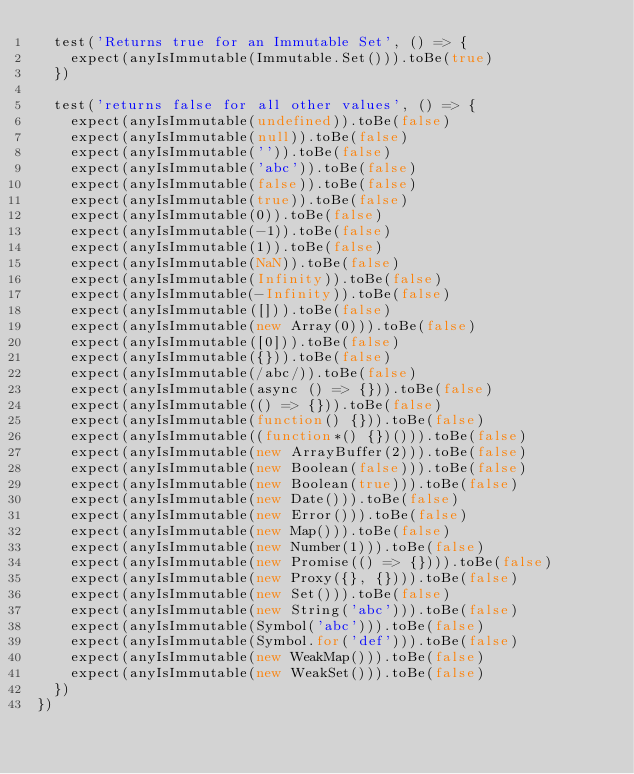<code> <loc_0><loc_0><loc_500><loc_500><_JavaScript_>  test('Returns true for an Immutable Set', () => {
    expect(anyIsImmutable(Immutable.Set())).toBe(true)
  })

  test('returns false for all other values', () => {
    expect(anyIsImmutable(undefined)).toBe(false)
    expect(anyIsImmutable(null)).toBe(false)
    expect(anyIsImmutable('')).toBe(false)
    expect(anyIsImmutable('abc')).toBe(false)
    expect(anyIsImmutable(false)).toBe(false)
    expect(anyIsImmutable(true)).toBe(false)
    expect(anyIsImmutable(0)).toBe(false)
    expect(anyIsImmutable(-1)).toBe(false)
    expect(anyIsImmutable(1)).toBe(false)
    expect(anyIsImmutable(NaN)).toBe(false)
    expect(anyIsImmutable(Infinity)).toBe(false)
    expect(anyIsImmutable(-Infinity)).toBe(false)
    expect(anyIsImmutable([])).toBe(false)
    expect(anyIsImmutable(new Array(0))).toBe(false)
    expect(anyIsImmutable([0])).toBe(false)
    expect(anyIsImmutable({})).toBe(false)
    expect(anyIsImmutable(/abc/)).toBe(false)
    expect(anyIsImmutable(async () => {})).toBe(false)
    expect(anyIsImmutable(() => {})).toBe(false)
    expect(anyIsImmutable(function() {})).toBe(false)
    expect(anyIsImmutable((function*() {})())).toBe(false)
    expect(anyIsImmutable(new ArrayBuffer(2))).toBe(false)
    expect(anyIsImmutable(new Boolean(false))).toBe(false)
    expect(anyIsImmutable(new Boolean(true))).toBe(false)
    expect(anyIsImmutable(new Date())).toBe(false)
    expect(anyIsImmutable(new Error())).toBe(false)
    expect(anyIsImmutable(new Map())).toBe(false)
    expect(anyIsImmutable(new Number(1))).toBe(false)
    expect(anyIsImmutable(new Promise(() => {}))).toBe(false)
    expect(anyIsImmutable(new Proxy({}, {}))).toBe(false)
    expect(anyIsImmutable(new Set())).toBe(false)
    expect(anyIsImmutable(new String('abc'))).toBe(false)
    expect(anyIsImmutable(Symbol('abc'))).toBe(false)
    expect(anyIsImmutable(Symbol.for('def'))).toBe(false)
    expect(anyIsImmutable(new WeakMap())).toBe(false)
    expect(anyIsImmutable(new WeakSet())).toBe(false)
  })
})
</code> 